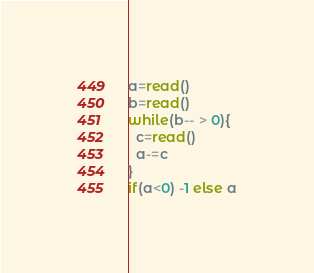Convert code to text. <code><loc_0><loc_0><loc_500><loc_500><_bc_>a=read()
b=read()
while(b-- > 0){
  c=read()
  a-=c
}
if(a<0) -1 else a
</code> 